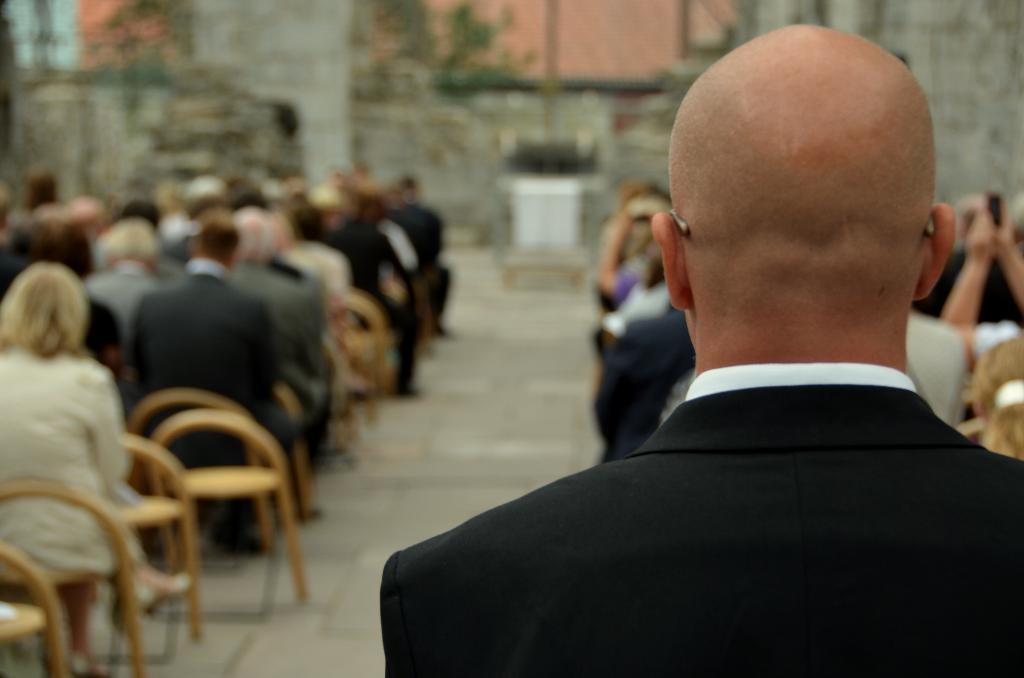Can you describe this image briefly? In this picture we can see a man in the black blazer. In front of the man, there are groups of people sitting on chairs and there are some blurred objects. 